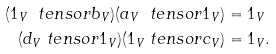<formula> <loc_0><loc_0><loc_500><loc_500>( 1 _ { V } \ t e n s o r b _ { V } ) ( a _ { V } \ t e n s o r 1 _ { V } ) & = 1 _ { V } \\ ( d _ { V } \ t e n s o r 1 _ { V } ) ( 1 _ { V } \ t e n s o r c _ { V } ) & = 1 _ { V } .</formula> 